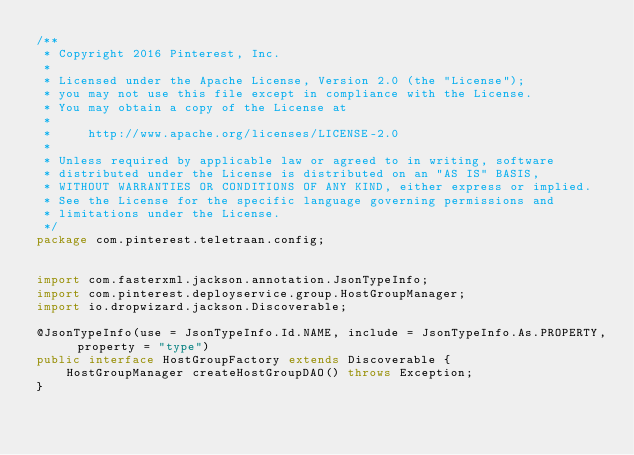Convert code to text. <code><loc_0><loc_0><loc_500><loc_500><_Java_>/**
 * Copyright 2016 Pinterest, Inc.
 *
 * Licensed under the Apache License, Version 2.0 (the "License");
 * you may not use this file except in compliance with the License.
 * You may obtain a copy of the License at
 *  
 *     http://www.apache.org/licenses/LICENSE-2.0
 *    
 * Unless required by applicable law or agreed to in writing, software
 * distributed under the License is distributed on an "AS IS" BASIS,
 * WITHOUT WARRANTIES OR CONDITIONS OF ANY KIND, either express or implied.
 * See the License for the specific language governing permissions and
 * limitations under the License.
 */
package com.pinterest.teletraan.config;


import com.fasterxml.jackson.annotation.JsonTypeInfo;
import com.pinterest.deployservice.group.HostGroupManager;
import io.dropwizard.jackson.Discoverable;

@JsonTypeInfo(use = JsonTypeInfo.Id.NAME, include = JsonTypeInfo.As.PROPERTY, property = "type")
public interface HostGroupFactory extends Discoverable {
    HostGroupManager createHostGroupDAO() throws Exception;
}
</code> 